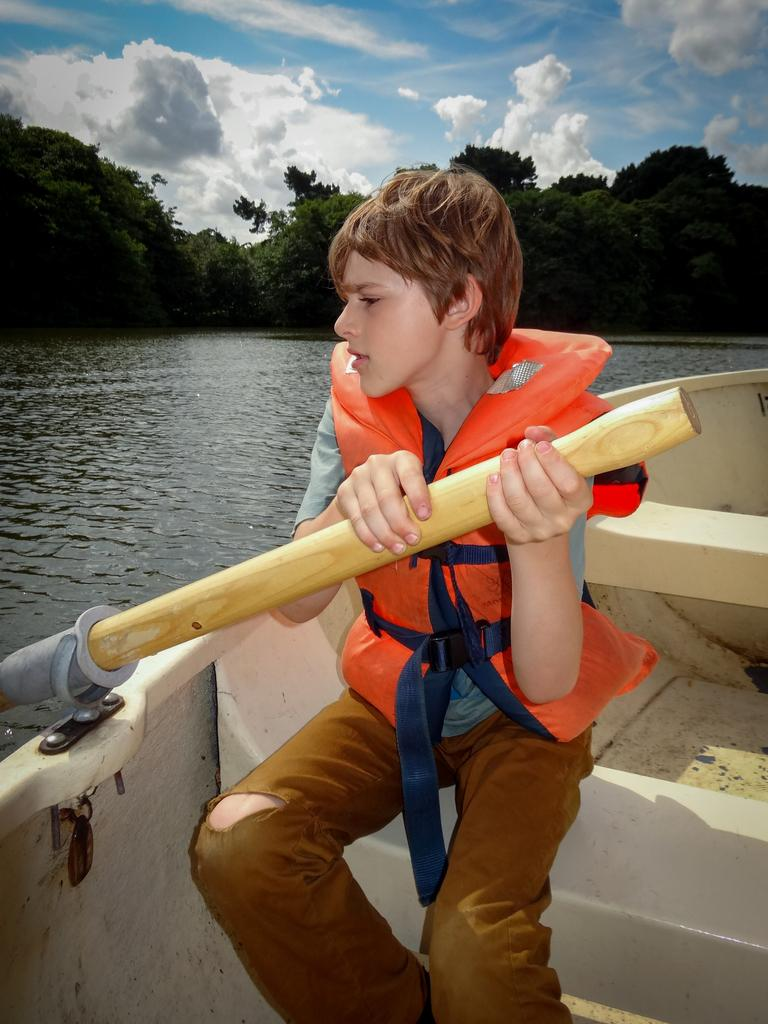What is the main subject in the foreground of the picture? There is a boy in the foreground of the picture. What is the boy doing in the picture? The boy is sitting on a boat. What is the boy holding in his hand? The boy is holding a paddle in his hand. What can be seen in the background of the image? There is water, trees, and clouds visible in the background of the image. What part of the sky is visible in the image? The sky is visible in the background of the image. Where is the sister of the boy in the picture? There is no mention of a sister in the image, so we cannot determine her location. What type of oven can be seen in the image? There is no oven present in the image. 